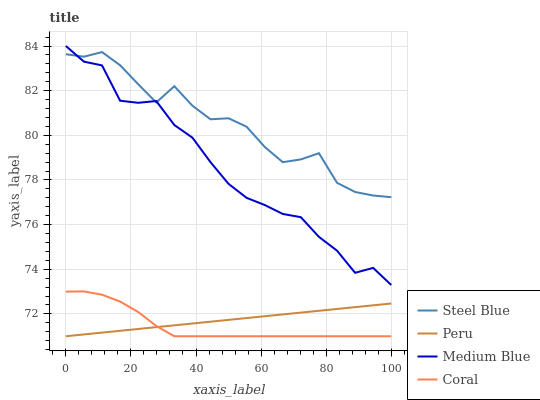Does Coral have the minimum area under the curve?
Answer yes or no. Yes. Does Steel Blue have the maximum area under the curve?
Answer yes or no. Yes. Does Medium Blue have the minimum area under the curve?
Answer yes or no. No. Does Medium Blue have the maximum area under the curve?
Answer yes or no. No. Is Peru the smoothest?
Answer yes or no. Yes. Is Medium Blue the roughest?
Answer yes or no. Yes. Is Steel Blue the smoothest?
Answer yes or no. No. Is Steel Blue the roughest?
Answer yes or no. No. Does Coral have the lowest value?
Answer yes or no. Yes. Does Medium Blue have the lowest value?
Answer yes or no. No. Does Medium Blue have the highest value?
Answer yes or no. Yes. Does Steel Blue have the highest value?
Answer yes or no. No. Is Coral less than Steel Blue?
Answer yes or no. Yes. Is Medium Blue greater than Peru?
Answer yes or no. Yes. Does Medium Blue intersect Steel Blue?
Answer yes or no. Yes. Is Medium Blue less than Steel Blue?
Answer yes or no. No. Is Medium Blue greater than Steel Blue?
Answer yes or no. No. Does Coral intersect Steel Blue?
Answer yes or no. No. 